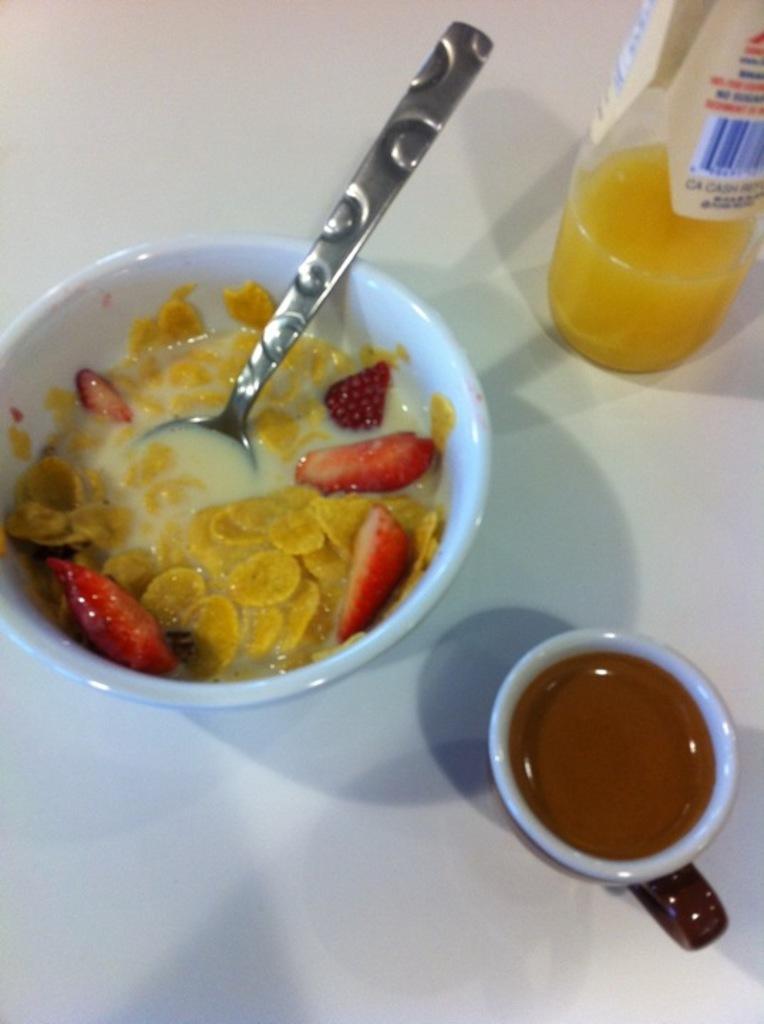How would you summarize this image in a sentence or two? In the image we can see there are corn flakes, milk and strawberry pieces in the bowl and there is spoon kept in the bowl. There is tea in the cup and there is juice bottle kept on the table. 